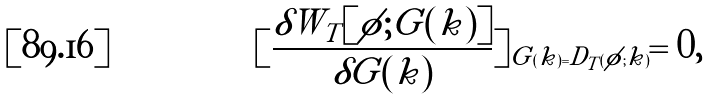<formula> <loc_0><loc_0><loc_500><loc_500>[ \frac { \delta W _ { T } [ \phi ; G ( k ) ] } { \delta G ( k ) } ] _ { G ( k ) = D _ { T } ( \phi ; k ) } = 0 ,</formula> 